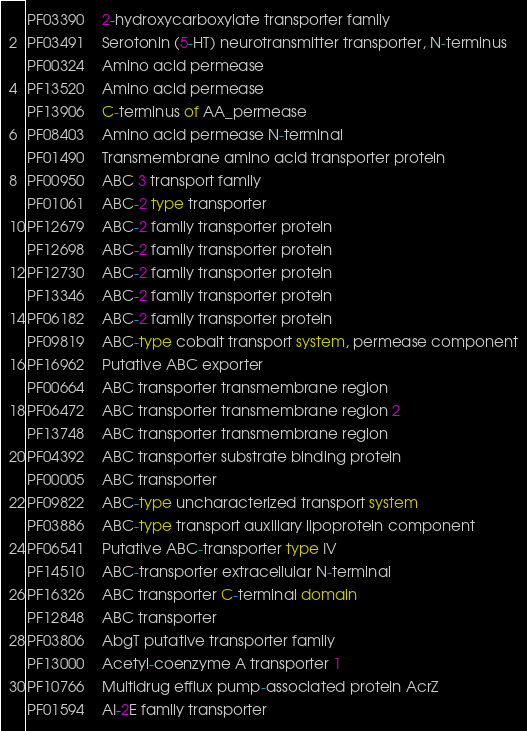<code> <loc_0><loc_0><loc_500><loc_500><_SQL_>PF03390	2-hydroxycarboxylate transporter family
PF03491	Serotonin (5-HT) neurotransmitter transporter, N-terminus
PF00324	Amino acid permease
PF13520	Amino acid permease
PF13906	C-terminus of AA_permease
PF08403	Amino acid permease N-terminal
PF01490	Transmembrane amino acid transporter protein
PF00950	ABC 3 transport family
PF01061	ABC-2 type transporter
PF12679	ABC-2 family transporter protein
PF12698	ABC-2 family transporter protein
PF12730	ABC-2 family transporter protein
PF13346	ABC-2 family transporter protein
PF06182	ABC-2 family transporter protein
PF09819	ABC-type cobalt transport system, permease component
PF16962	Putative ABC exporter
PF00664	ABC transporter transmembrane region
PF06472	ABC transporter transmembrane region 2
PF13748	ABC transporter transmembrane region
PF04392	ABC transporter substrate binding protein
PF00005	ABC transporter
PF09822	ABC-type uncharacterized transport system
PF03886	ABC-type transport auxiliary lipoprotein component
PF06541	Putative ABC-transporter type IV
PF14510	ABC-transporter extracellular N-terminal
PF16326	ABC transporter C-terminal domain
PF12848	ABC transporter
PF03806	AbgT putative transporter family
PF13000	Acetyl-coenzyme A transporter 1
PF10766	Multidrug efflux pump-associated protein AcrZ
PF01594	AI-2E family transporter</code> 